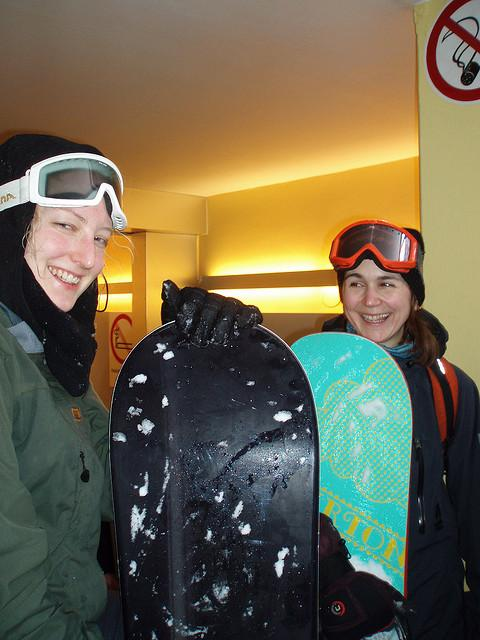What can't be done in this room?

Choices:
A) drinking
B) smoking
C) dancing
D) talking smoking 